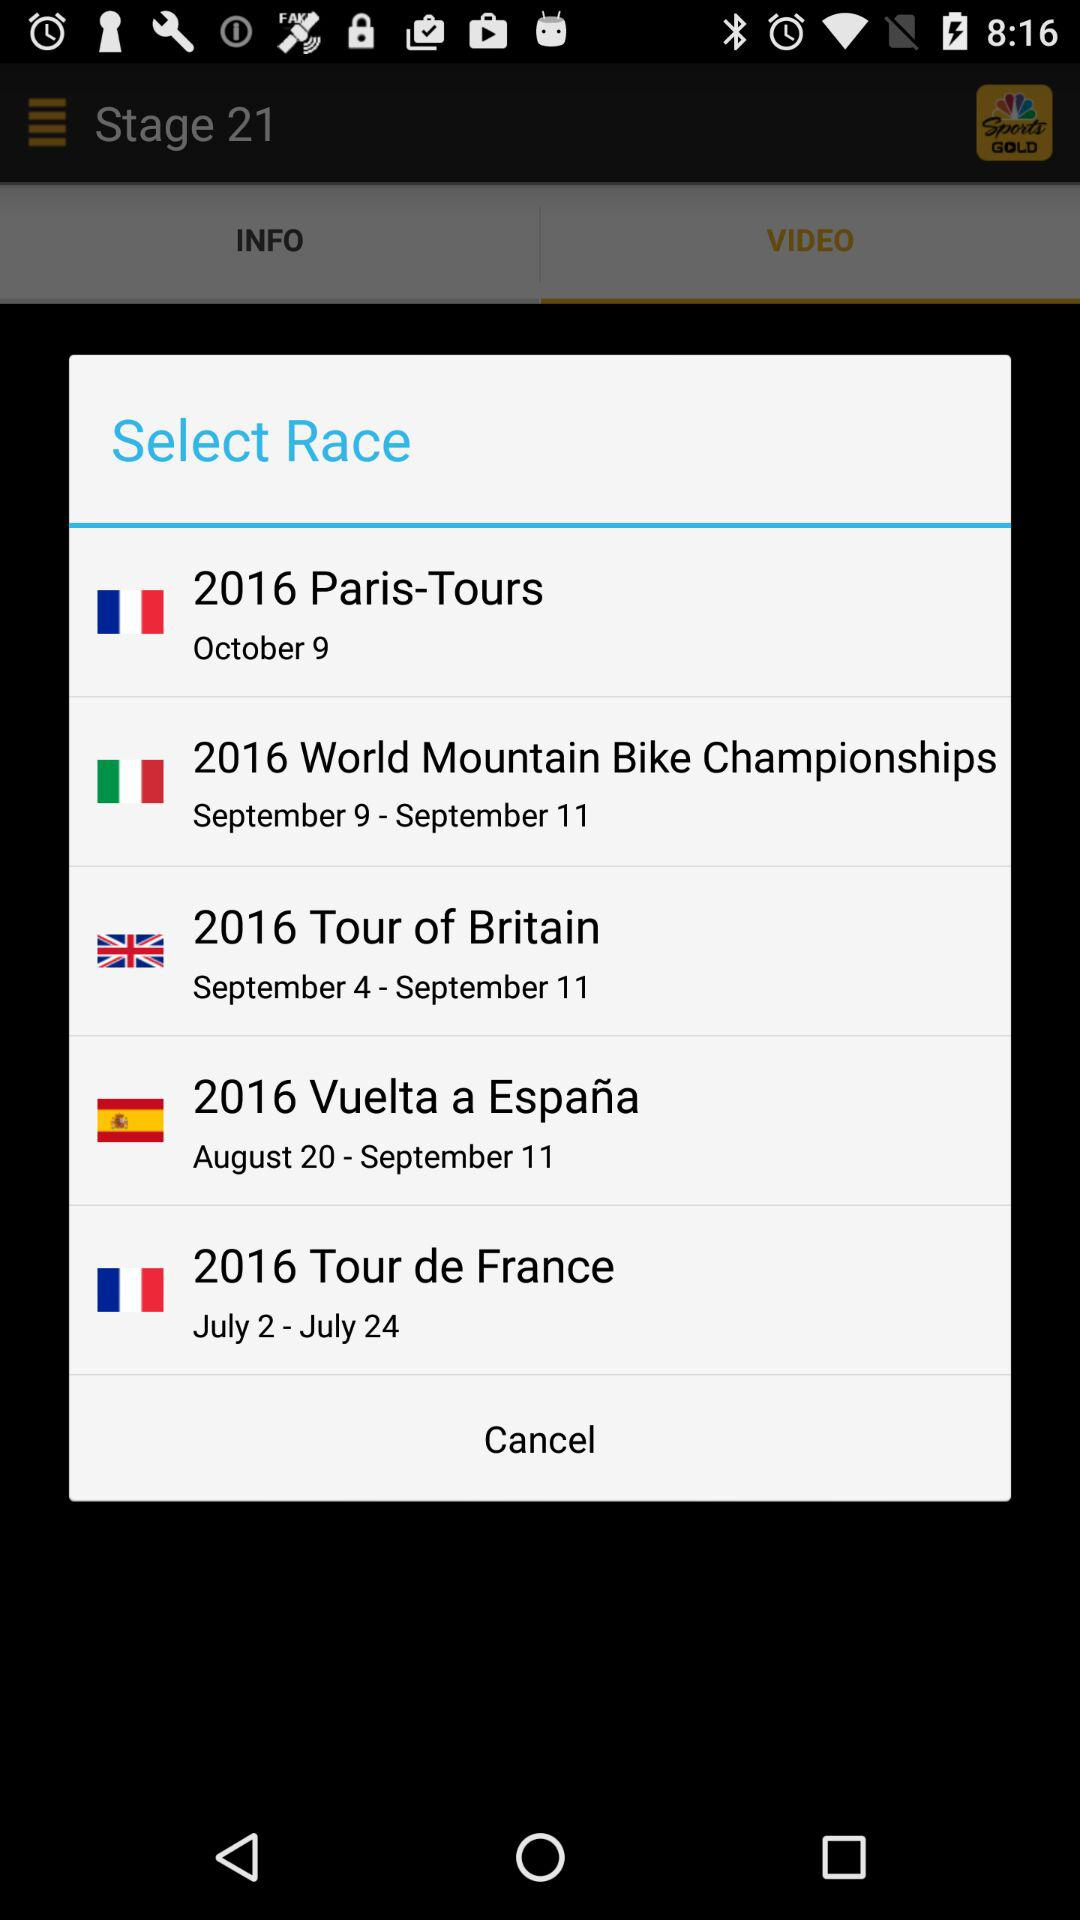What is the duration of the "2016 Tour of Britain"? The duration of the "2016 Tour of Britain" is from September 4 to September 11. 